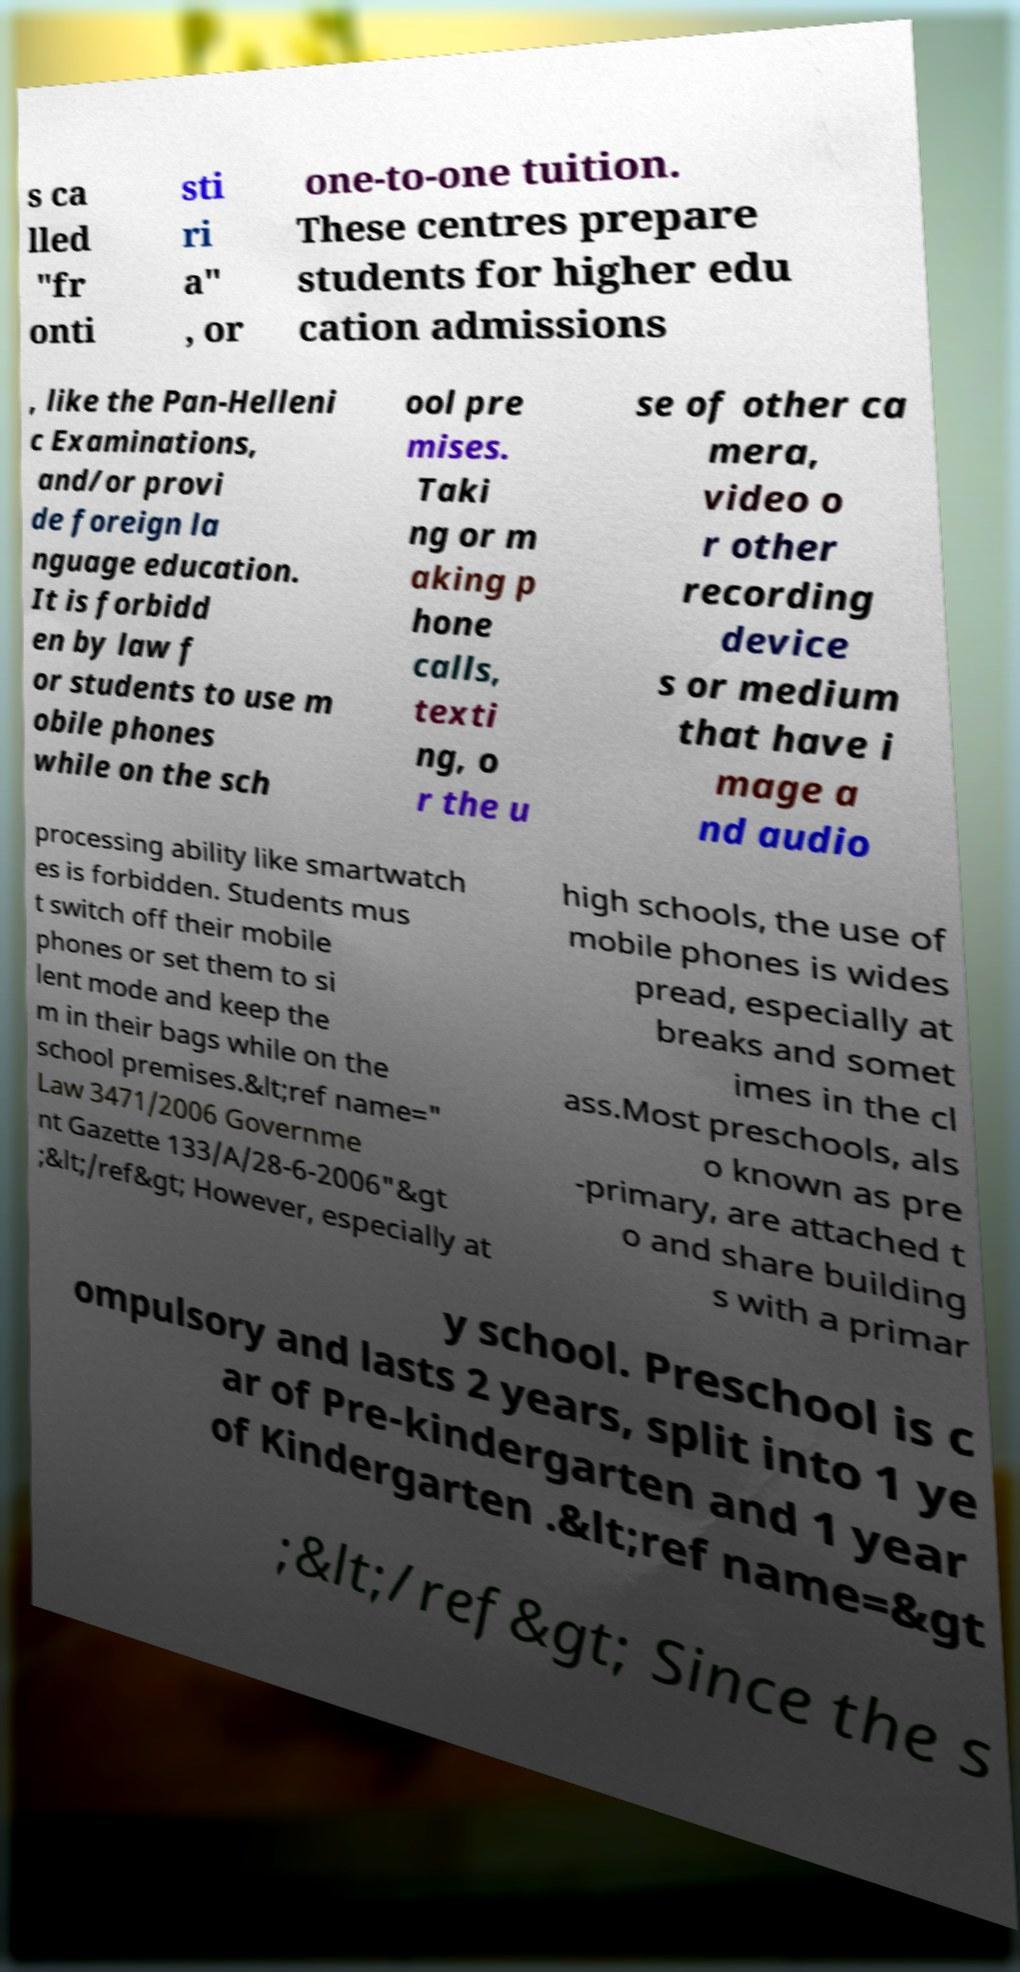Please read and relay the text visible in this image. What does it say? s ca lled "fr onti sti ri a" , or one-to-one tuition. These centres prepare students for higher edu cation admissions , like the Pan-Helleni c Examinations, and/or provi de foreign la nguage education. It is forbidd en by law f or students to use m obile phones while on the sch ool pre mises. Taki ng or m aking p hone calls, texti ng, o r the u se of other ca mera, video o r other recording device s or medium that have i mage a nd audio processing ability like smartwatch es is forbidden. Students mus t switch off their mobile phones or set them to si lent mode and keep the m in their bags while on the school premises.&lt;ref name=" Law 3471/2006 Governme nt Gazette 133/A/28-6-2006"&gt ;&lt;/ref&gt; However, especially at high schools, the use of mobile phones is wides pread, especially at breaks and somet imes in the cl ass.Most preschools, als o known as pre -primary, are attached t o and share building s with a primar y school. Preschool is c ompulsory and lasts 2 years, split into 1 ye ar of Pre-kindergarten and 1 year of Kindergarten .&lt;ref name=&gt ;&lt;/ref&gt; Since the s 